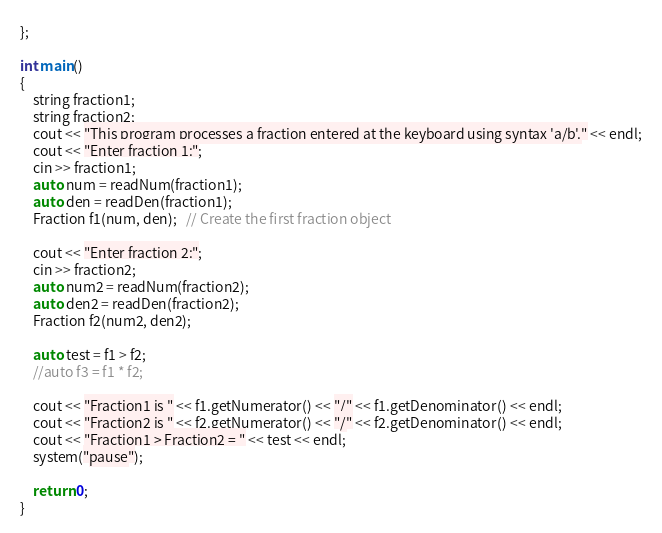Convert code to text. <code><loc_0><loc_0><loc_500><loc_500><_C++_>};

int main()
{
	string fraction1;
	string fraction2;
	cout << "This program processes a fraction entered at the keyboard using syntax 'a/b'." << endl;
	cout << "Enter fraction 1:";
	cin >> fraction1;
	auto num = readNum(fraction1);
	auto den = readDen(fraction1);
	Fraction f1(num, den);   // Create the first fraction object
	
	cout << "Enter fraction 2:";
	cin >> fraction2;
	auto num2 = readNum(fraction2);
	auto den2 = readDen(fraction2);
	Fraction f2(num2, den2);

	auto test = f1 > f2;
	//auto f3 = f1 * f2;

	cout << "Fraction1 is " << f1.getNumerator() << "/" << f1.getDenominator() << endl;
	cout << "Fraction2 is " << f2.getNumerator() << "/" << f2.getDenominator() << endl;
	cout << "Fraction1 > Fraction2 = " << test << endl;
	system("pause");

	return 0;
}</code> 